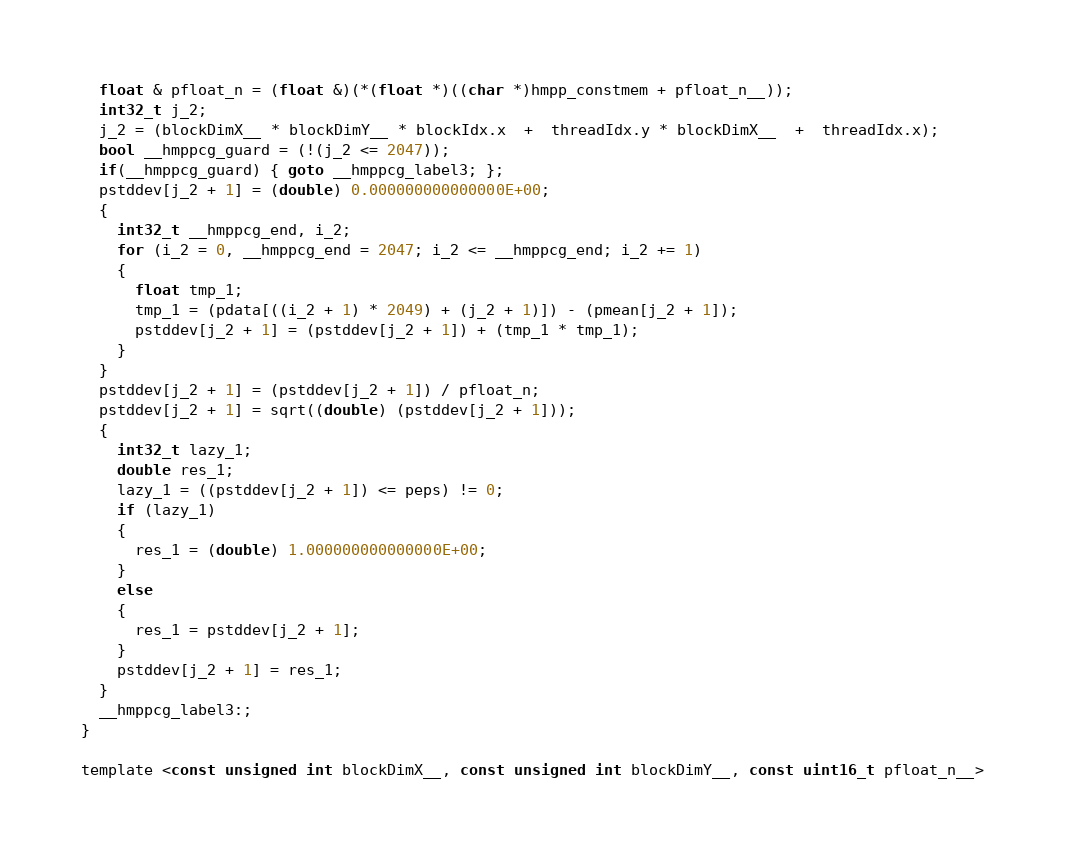Convert code to text. <code><loc_0><loc_0><loc_500><loc_500><_Cuda_>  float & pfloat_n = (float &)(*(float *)((char *)hmpp_constmem + pfloat_n__));
  int32_t j_2;
  j_2 = (blockDimX__ * blockDimY__ * blockIdx.x  +  threadIdx.y * blockDimX__  +  threadIdx.x);
  bool __hmppcg_guard = (!(j_2 <= 2047));
  if(__hmppcg_guard) { goto __hmppcg_label3; };
  pstddev[j_2 + 1] = (double) 0.000000000000000E+00;
  {
    int32_t __hmppcg_end, i_2;
    for (i_2 = 0, __hmppcg_end = 2047; i_2 <= __hmppcg_end; i_2 += 1)
    {
      float tmp_1;
      tmp_1 = (pdata[((i_2 + 1) * 2049) + (j_2 + 1)]) - (pmean[j_2 + 1]);
      pstddev[j_2 + 1] = (pstddev[j_2 + 1]) + (tmp_1 * tmp_1);
    } 
  }
  pstddev[j_2 + 1] = (pstddev[j_2 + 1]) / pfloat_n;
  pstddev[j_2 + 1] = sqrt((double) (pstddev[j_2 + 1]));
  {
    int32_t lazy_1;
    double res_1;
    lazy_1 = ((pstddev[j_2 + 1]) <= peps) != 0;
    if (lazy_1)
    {
      res_1 = (double) 1.000000000000000E+00;
    } 
    else
    {
      res_1 = pstddev[j_2 + 1];
    } 
    pstddev[j_2 + 1] = res_1;
  } 
  __hmppcg_label3:;
} 

template <const unsigned int blockDimX__, const unsigned int blockDimY__, const uint16_t pfloat_n__></code> 